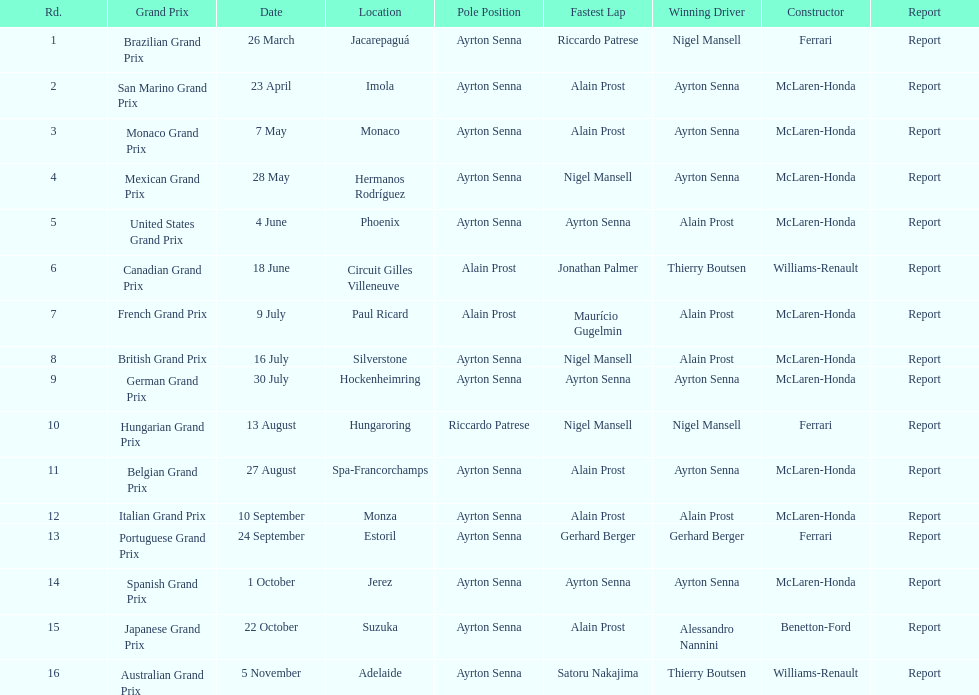When prost claimed the drivers' title, who was his partner on the team? Ayrton Senna. I'm looking to parse the entire table for insights. Could you assist me with that? {'header': ['Rd.', 'Grand Prix', 'Date', 'Location', 'Pole Position', 'Fastest Lap', 'Winning Driver', 'Constructor', 'Report'], 'rows': [['1', 'Brazilian Grand Prix', '26 March', 'Jacarepaguá', 'Ayrton Senna', 'Riccardo Patrese', 'Nigel Mansell', 'Ferrari', 'Report'], ['2', 'San Marino Grand Prix', '23 April', 'Imola', 'Ayrton Senna', 'Alain Prost', 'Ayrton Senna', 'McLaren-Honda', 'Report'], ['3', 'Monaco Grand Prix', '7 May', 'Monaco', 'Ayrton Senna', 'Alain Prost', 'Ayrton Senna', 'McLaren-Honda', 'Report'], ['4', 'Mexican Grand Prix', '28 May', 'Hermanos Rodríguez', 'Ayrton Senna', 'Nigel Mansell', 'Ayrton Senna', 'McLaren-Honda', 'Report'], ['5', 'United States Grand Prix', '4 June', 'Phoenix', 'Ayrton Senna', 'Ayrton Senna', 'Alain Prost', 'McLaren-Honda', 'Report'], ['6', 'Canadian Grand Prix', '18 June', 'Circuit Gilles Villeneuve', 'Alain Prost', 'Jonathan Palmer', 'Thierry Boutsen', 'Williams-Renault', 'Report'], ['7', 'French Grand Prix', '9 July', 'Paul Ricard', 'Alain Prost', 'Maurício Gugelmin', 'Alain Prost', 'McLaren-Honda', 'Report'], ['8', 'British Grand Prix', '16 July', 'Silverstone', 'Ayrton Senna', 'Nigel Mansell', 'Alain Prost', 'McLaren-Honda', 'Report'], ['9', 'German Grand Prix', '30 July', 'Hockenheimring', 'Ayrton Senna', 'Ayrton Senna', 'Ayrton Senna', 'McLaren-Honda', 'Report'], ['10', 'Hungarian Grand Prix', '13 August', 'Hungaroring', 'Riccardo Patrese', 'Nigel Mansell', 'Nigel Mansell', 'Ferrari', 'Report'], ['11', 'Belgian Grand Prix', '27 August', 'Spa-Francorchamps', 'Ayrton Senna', 'Alain Prost', 'Ayrton Senna', 'McLaren-Honda', 'Report'], ['12', 'Italian Grand Prix', '10 September', 'Monza', 'Ayrton Senna', 'Alain Prost', 'Alain Prost', 'McLaren-Honda', 'Report'], ['13', 'Portuguese Grand Prix', '24 September', 'Estoril', 'Ayrton Senna', 'Gerhard Berger', 'Gerhard Berger', 'Ferrari', 'Report'], ['14', 'Spanish Grand Prix', '1 October', 'Jerez', 'Ayrton Senna', 'Ayrton Senna', 'Ayrton Senna', 'McLaren-Honda', 'Report'], ['15', 'Japanese Grand Prix', '22 October', 'Suzuka', 'Ayrton Senna', 'Alain Prost', 'Alessandro Nannini', 'Benetton-Ford', 'Report'], ['16', 'Australian Grand Prix', '5 November', 'Adelaide', 'Ayrton Senna', 'Satoru Nakajima', 'Thierry Boutsen', 'Williams-Renault', 'Report']]} 